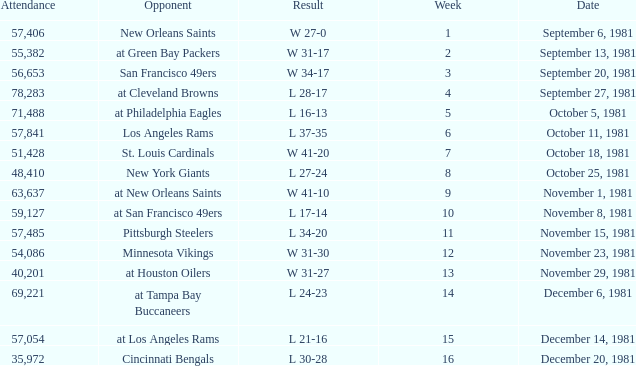What was the average number of attendance for the game on November 29, 1981 played after week 13? None. 